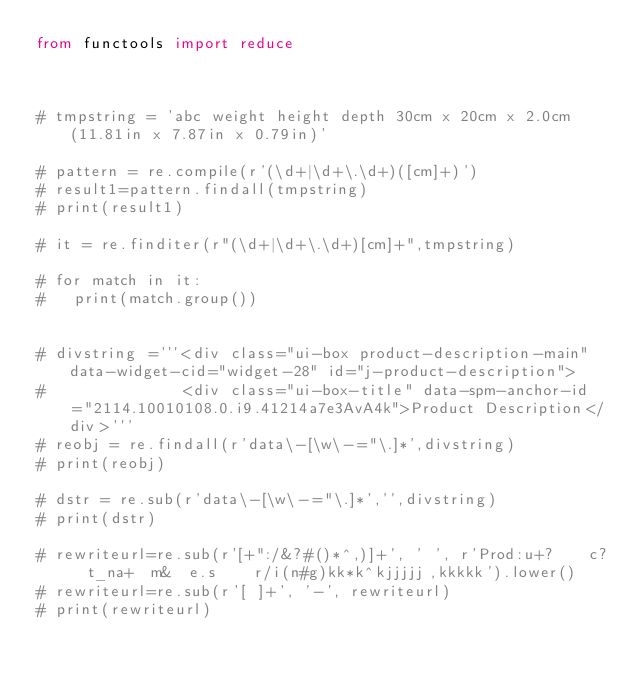<code> <loc_0><loc_0><loc_500><loc_500><_Python_>from functools import reduce



# tmpstring = 'abc weight height depth 30cm x 20cm x 2.0cm (11.81in x 7.87in x 0.79in)'

# pattern = re.compile(r'(\d+|\d+\.\d+)([cm]+)')
# result1=pattern.findall(tmpstring)
# print(result1)

# it = re.finditer(r"(\d+|\d+\.\d+)[cm]+",tmpstring)

# for match in it:
# 	print(match.group())


# divstring ='''<div class="ui-box product-description-main" data-widget-cid="widget-28" id="j-product-description">
# 				<div class="ui-box-title" data-spm-anchor-id="2114.10010108.0.i9.41214a7e3AvA4k">Product Description</div>'''
# reobj = re.findall(r'data\-[\w\-="\.]*',divstring)
# print(reobj)

# dstr = re.sub(r'data\-[\w\-="\.]*','',divstring)
# print(dstr)

# rewriteurl=re.sub(r'[+":/&?#()*^,)]+', ' ', r'Prod:u+?    c?  t_na+  m&  e.s    r/i(n#g)kk*k^kjjjjj,kkkkk').lower()
# rewriteurl=re.sub(r'[ ]+', '-', rewriteurl)
# print(rewriteurl)
</code> 